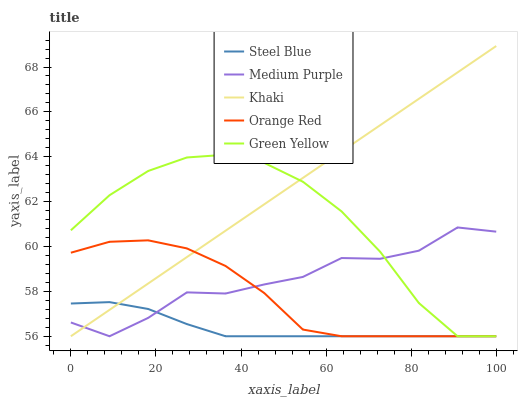Does Steel Blue have the minimum area under the curve?
Answer yes or no. Yes. Does Khaki have the maximum area under the curve?
Answer yes or no. Yes. Does Green Yellow have the minimum area under the curve?
Answer yes or no. No. Does Green Yellow have the maximum area under the curve?
Answer yes or no. No. Is Khaki the smoothest?
Answer yes or no. Yes. Is Medium Purple the roughest?
Answer yes or no. Yes. Is Green Yellow the smoothest?
Answer yes or no. No. Is Green Yellow the roughest?
Answer yes or no. No. Does Khaki have the highest value?
Answer yes or no. Yes. Does Green Yellow have the highest value?
Answer yes or no. No. Does Medium Purple intersect Green Yellow?
Answer yes or no. Yes. Is Medium Purple less than Green Yellow?
Answer yes or no. No. Is Medium Purple greater than Green Yellow?
Answer yes or no. No. 